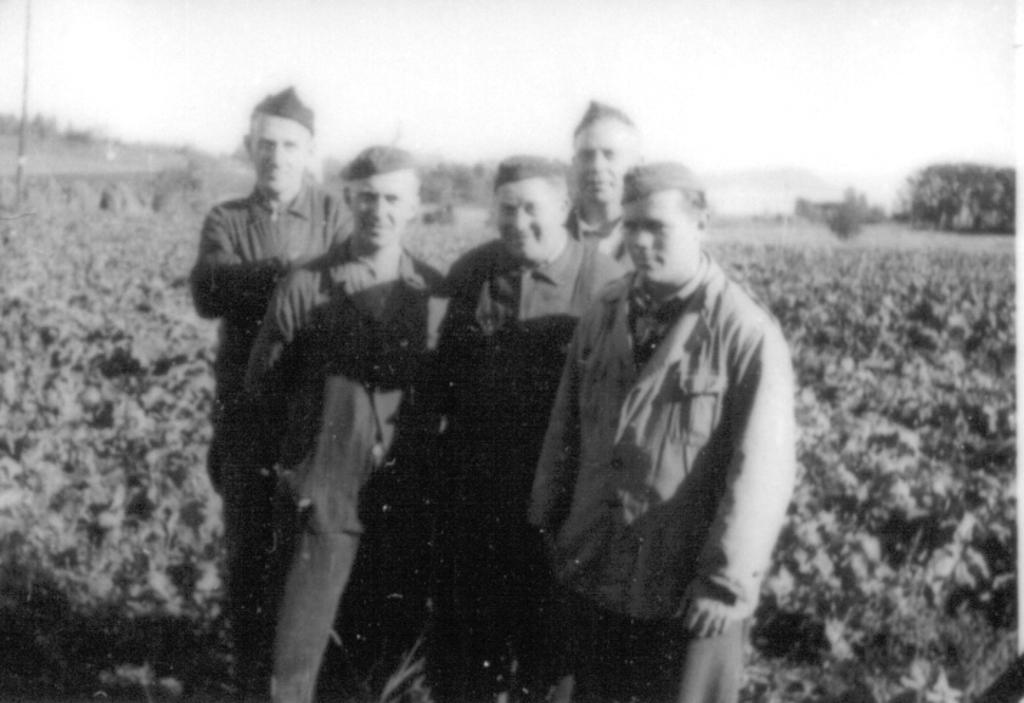How many people are in the image? There are five people in the image. What are the people doing in the image? The people are standing and posing for a photo. What can be seen in the background of the image? There are small plants visible in the background. What is the color scheme of the image? The image is black and white. Can you see any ghosts or mice in the image? No, there are no ghosts or mice present in the image. What type of tray is being used by the people in the image? There is no tray visible in the image; it only features the five people posing for a photo. 